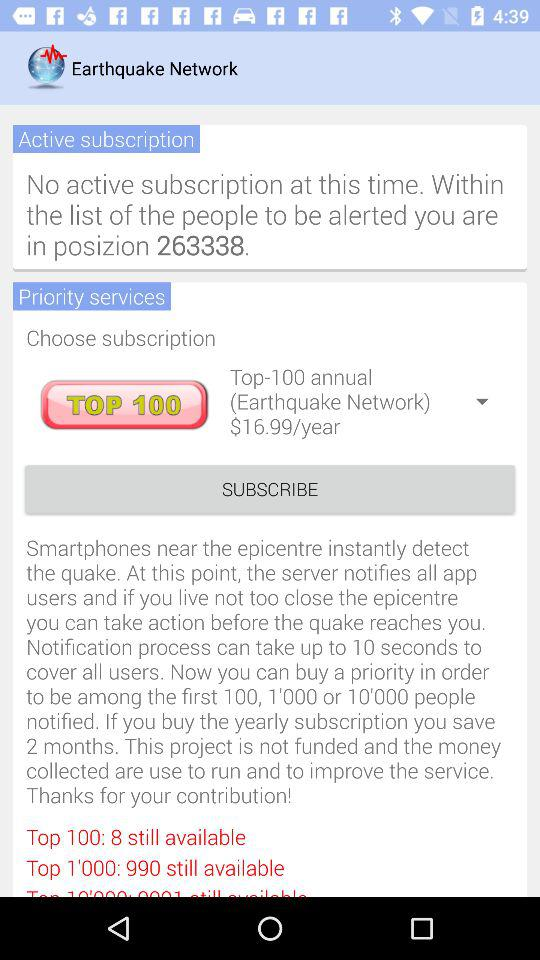How many numbers are still available in the top 100? There are 8 numbers that are still available in the top 100. 